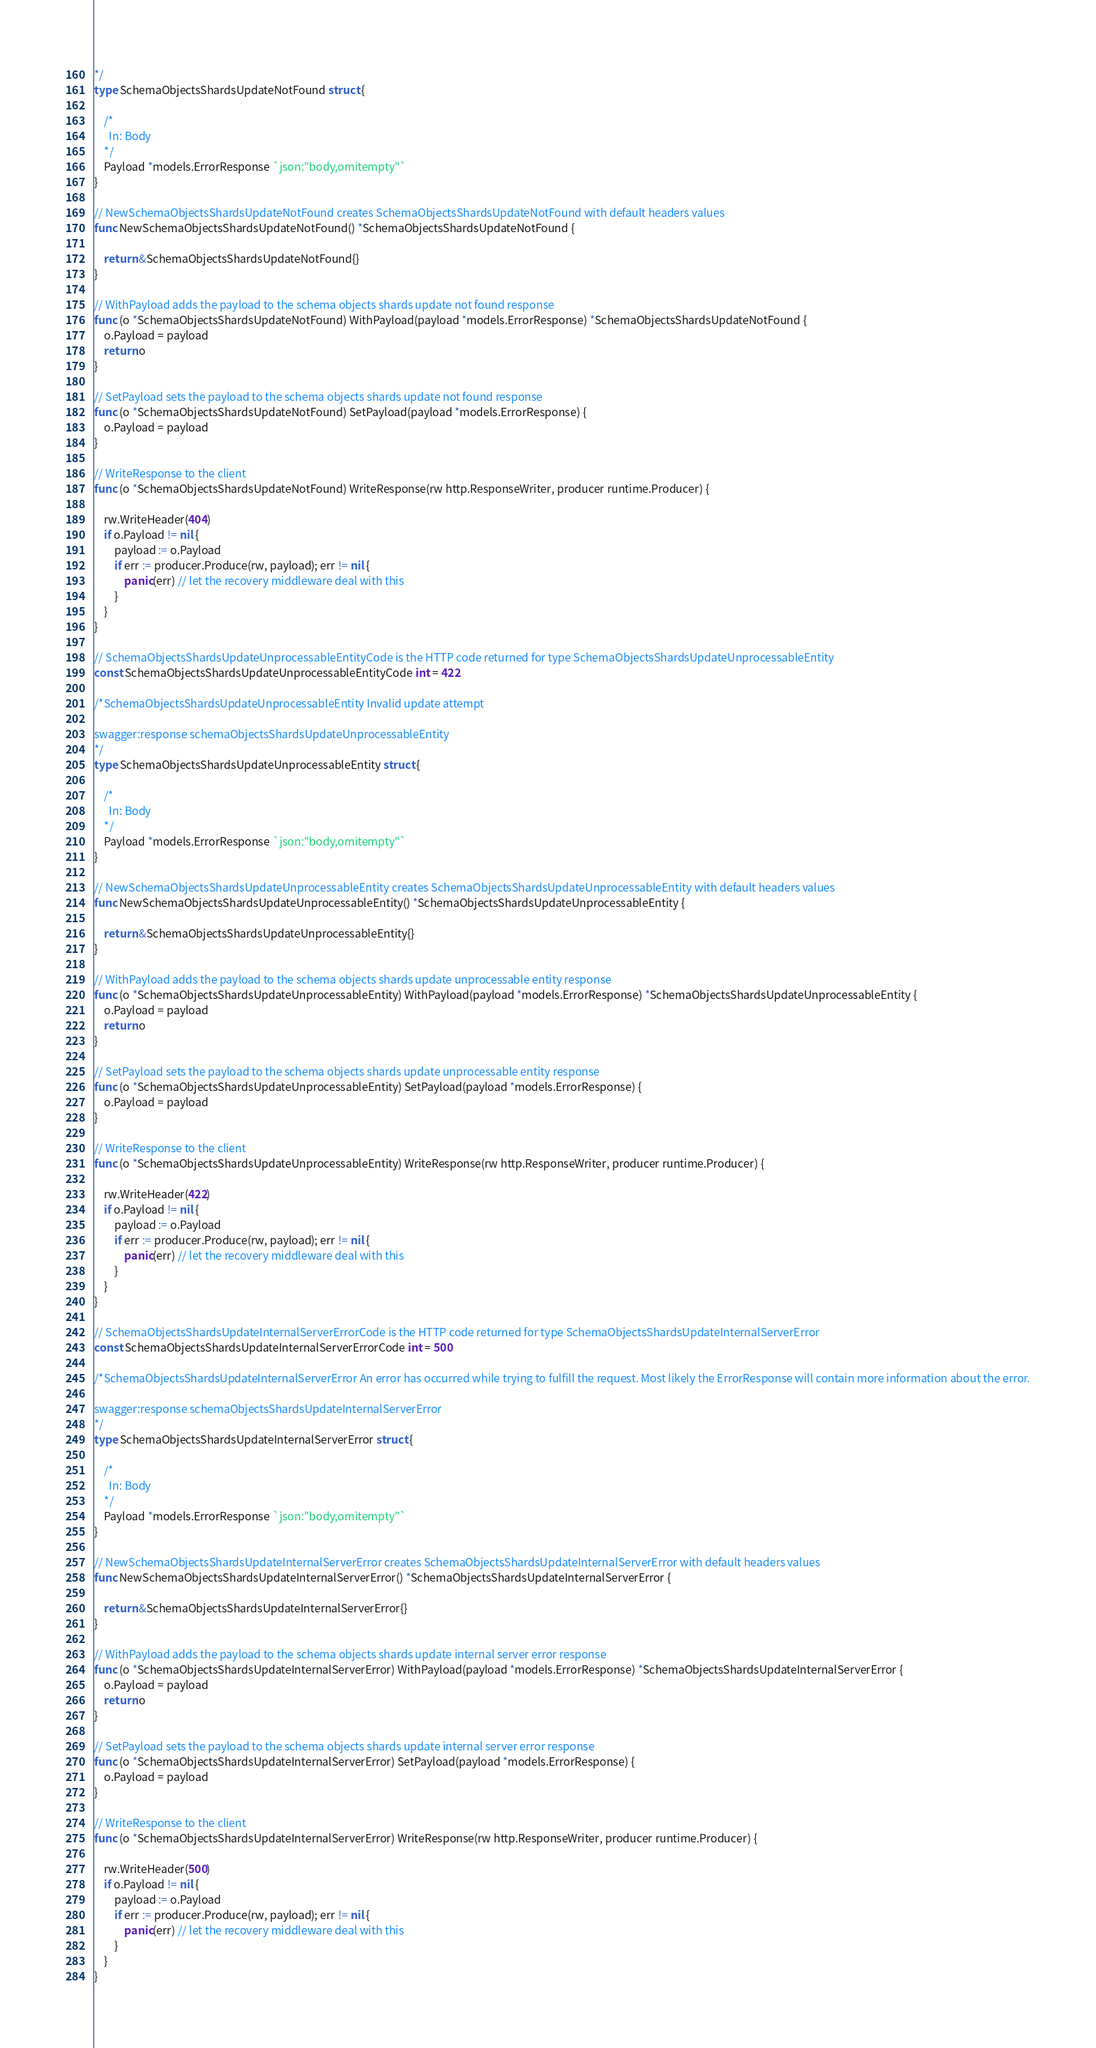Convert code to text. <code><loc_0><loc_0><loc_500><loc_500><_Go_>*/
type SchemaObjectsShardsUpdateNotFound struct {

	/*
	  In: Body
	*/
	Payload *models.ErrorResponse `json:"body,omitempty"`
}

// NewSchemaObjectsShardsUpdateNotFound creates SchemaObjectsShardsUpdateNotFound with default headers values
func NewSchemaObjectsShardsUpdateNotFound() *SchemaObjectsShardsUpdateNotFound {

	return &SchemaObjectsShardsUpdateNotFound{}
}

// WithPayload adds the payload to the schema objects shards update not found response
func (o *SchemaObjectsShardsUpdateNotFound) WithPayload(payload *models.ErrorResponse) *SchemaObjectsShardsUpdateNotFound {
	o.Payload = payload
	return o
}

// SetPayload sets the payload to the schema objects shards update not found response
func (o *SchemaObjectsShardsUpdateNotFound) SetPayload(payload *models.ErrorResponse) {
	o.Payload = payload
}

// WriteResponse to the client
func (o *SchemaObjectsShardsUpdateNotFound) WriteResponse(rw http.ResponseWriter, producer runtime.Producer) {

	rw.WriteHeader(404)
	if o.Payload != nil {
		payload := o.Payload
		if err := producer.Produce(rw, payload); err != nil {
			panic(err) // let the recovery middleware deal with this
		}
	}
}

// SchemaObjectsShardsUpdateUnprocessableEntityCode is the HTTP code returned for type SchemaObjectsShardsUpdateUnprocessableEntity
const SchemaObjectsShardsUpdateUnprocessableEntityCode int = 422

/*SchemaObjectsShardsUpdateUnprocessableEntity Invalid update attempt

swagger:response schemaObjectsShardsUpdateUnprocessableEntity
*/
type SchemaObjectsShardsUpdateUnprocessableEntity struct {

	/*
	  In: Body
	*/
	Payload *models.ErrorResponse `json:"body,omitempty"`
}

// NewSchemaObjectsShardsUpdateUnprocessableEntity creates SchemaObjectsShardsUpdateUnprocessableEntity with default headers values
func NewSchemaObjectsShardsUpdateUnprocessableEntity() *SchemaObjectsShardsUpdateUnprocessableEntity {

	return &SchemaObjectsShardsUpdateUnprocessableEntity{}
}

// WithPayload adds the payload to the schema objects shards update unprocessable entity response
func (o *SchemaObjectsShardsUpdateUnprocessableEntity) WithPayload(payload *models.ErrorResponse) *SchemaObjectsShardsUpdateUnprocessableEntity {
	o.Payload = payload
	return o
}

// SetPayload sets the payload to the schema objects shards update unprocessable entity response
func (o *SchemaObjectsShardsUpdateUnprocessableEntity) SetPayload(payload *models.ErrorResponse) {
	o.Payload = payload
}

// WriteResponse to the client
func (o *SchemaObjectsShardsUpdateUnprocessableEntity) WriteResponse(rw http.ResponseWriter, producer runtime.Producer) {

	rw.WriteHeader(422)
	if o.Payload != nil {
		payload := o.Payload
		if err := producer.Produce(rw, payload); err != nil {
			panic(err) // let the recovery middleware deal with this
		}
	}
}

// SchemaObjectsShardsUpdateInternalServerErrorCode is the HTTP code returned for type SchemaObjectsShardsUpdateInternalServerError
const SchemaObjectsShardsUpdateInternalServerErrorCode int = 500

/*SchemaObjectsShardsUpdateInternalServerError An error has occurred while trying to fulfill the request. Most likely the ErrorResponse will contain more information about the error.

swagger:response schemaObjectsShardsUpdateInternalServerError
*/
type SchemaObjectsShardsUpdateInternalServerError struct {

	/*
	  In: Body
	*/
	Payload *models.ErrorResponse `json:"body,omitempty"`
}

// NewSchemaObjectsShardsUpdateInternalServerError creates SchemaObjectsShardsUpdateInternalServerError with default headers values
func NewSchemaObjectsShardsUpdateInternalServerError() *SchemaObjectsShardsUpdateInternalServerError {

	return &SchemaObjectsShardsUpdateInternalServerError{}
}

// WithPayload adds the payload to the schema objects shards update internal server error response
func (o *SchemaObjectsShardsUpdateInternalServerError) WithPayload(payload *models.ErrorResponse) *SchemaObjectsShardsUpdateInternalServerError {
	o.Payload = payload
	return o
}

// SetPayload sets the payload to the schema objects shards update internal server error response
func (o *SchemaObjectsShardsUpdateInternalServerError) SetPayload(payload *models.ErrorResponse) {
	o.Payload = payload
}

// WriteResponse to the client
func (o *SchemaObjectsShardsUpdateInternalServerError) WriteResponse(rw http.ResponseWriter, producer runtime.Producer) {

	rw.WriteHeader(500)
	if o.Payload != nil {
		payload := o.Payload
		if err := producer.Produce(rw, payload); err != nil {
			panic(err) // let the recovery middleware deal with this
		}
	}
}
</code> 